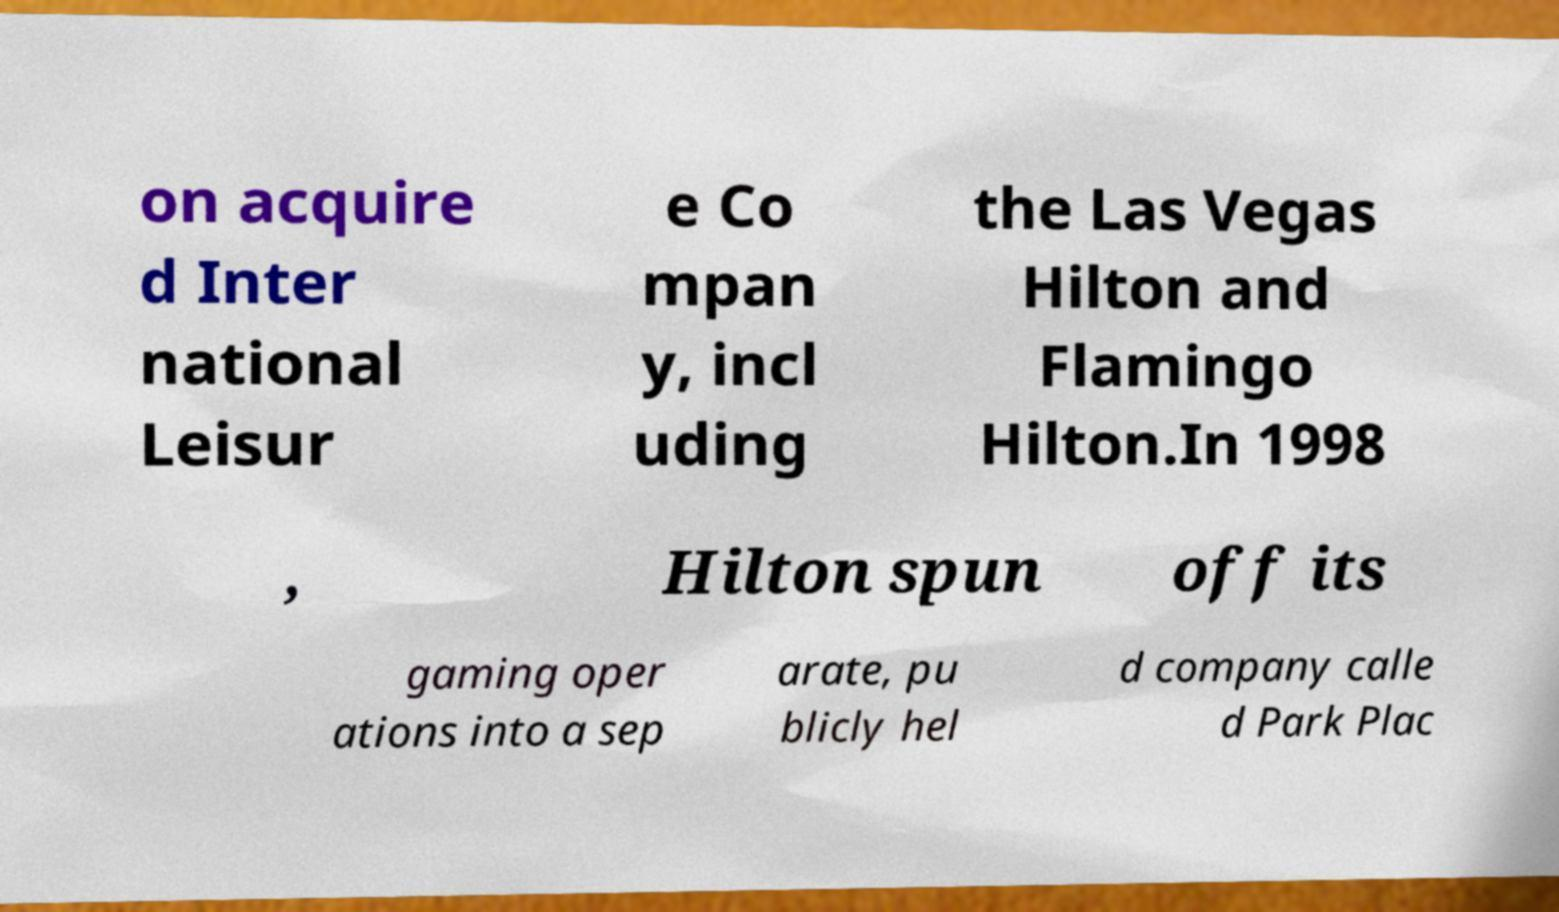Can you accurately transcribe the text from the provided image for me? on acquire d Inter national Leisur e Co mpan y, incl uding the Las Vegas Hilton and Flamingo Hilton.In 1998 , Hilton spun off its gaming oper ations into a sep arate, pu blicly hel d company calle d Park Plac 